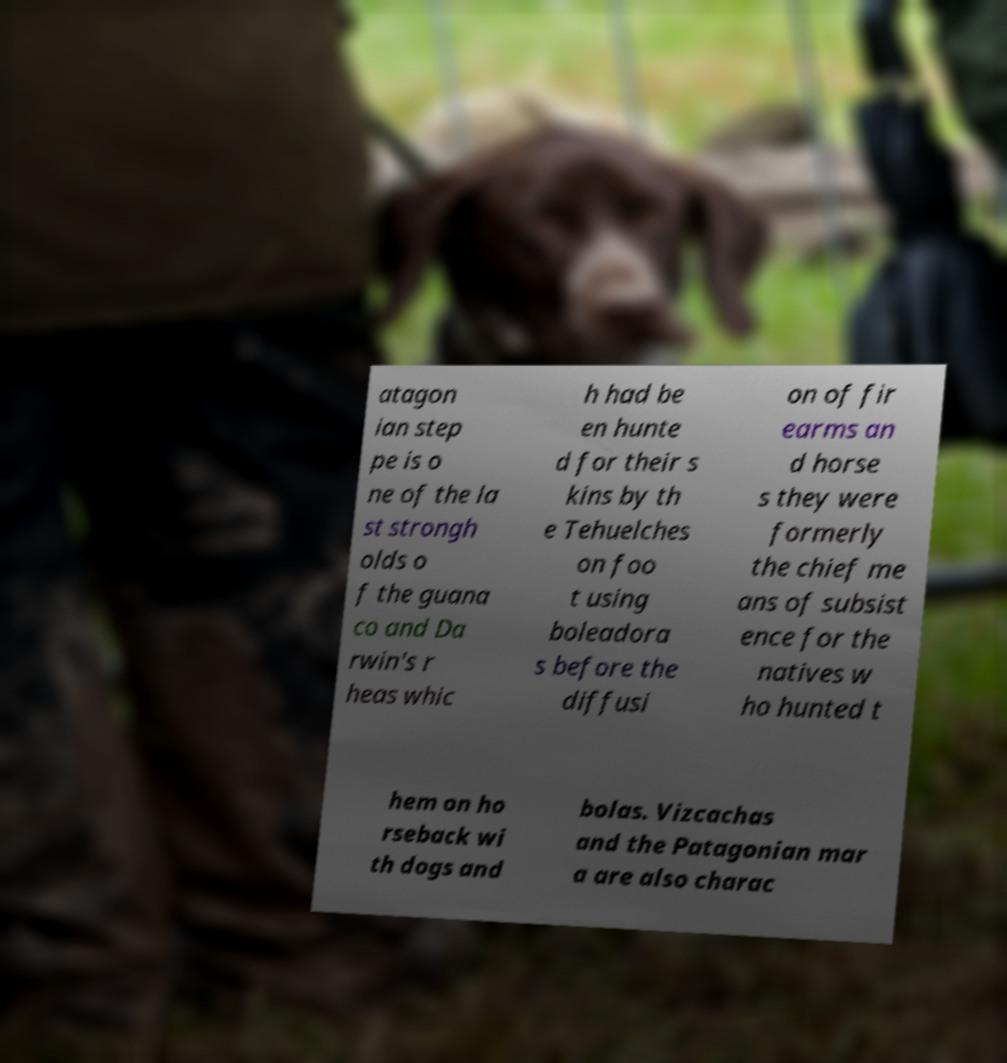Could you assist in decoding the text presented in this image and type it out clearly? atagon ian step pe is o ne of the la st strongh olds o f the guana co and Da rwin's r heas whic h had be en hunte d for their s kins by th e Tehuelches on foo t using boleadora s before the diffusi on of fir earms an d horse s they were formerly the chief me ans of subsist ence for the natives w ho hunted t hem on ho rseback wi th dogs and bolas. Vizcachas and the Patagonian mar a are also charac 